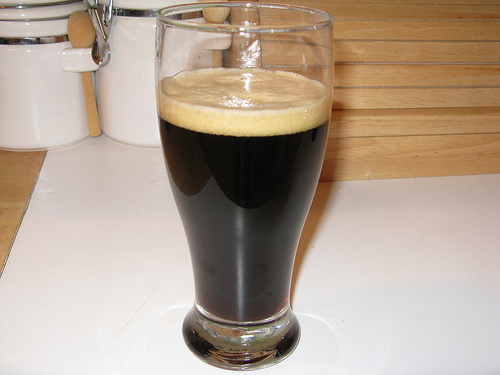<image>
Can you confirm if the beer is in the glass? Yes. The beer is contained within or inside the glass, showing a containment relationship. Where is the glass in relation to the counter? Is it in the counter? No. The glass is not contained within the counter. These objects have a different spatial relationship. 